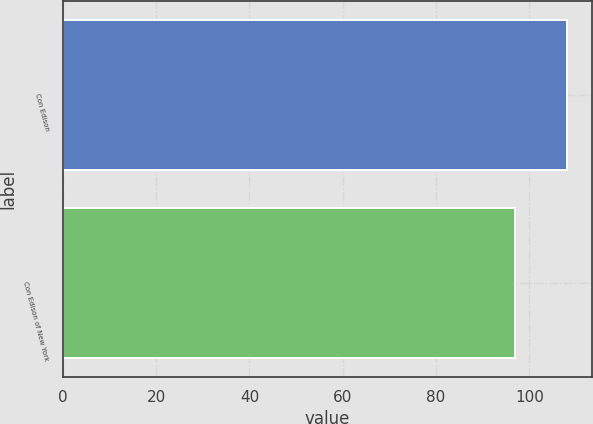<chart> <loc_0><loc_0><loc_500><loc_500><bar_chart><fcel>Con Edison<fcel>Con Edison of New York<nl><fcel>108<fcel>97<nl></chart> 